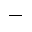Convert formula to latex. <formula><loc_0><loc_0><loc_500><loc_500>^ { - }</formula> 